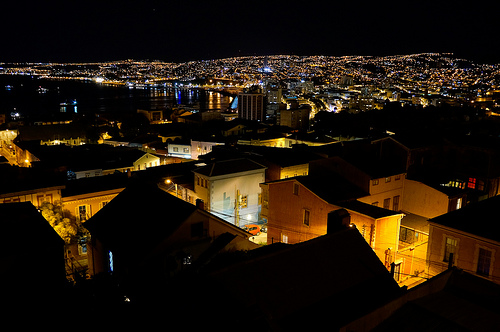<image>
Can you confirm if the city is next to the house? No. The city is not positioned next to the house. They are located in different areas of the scene. 